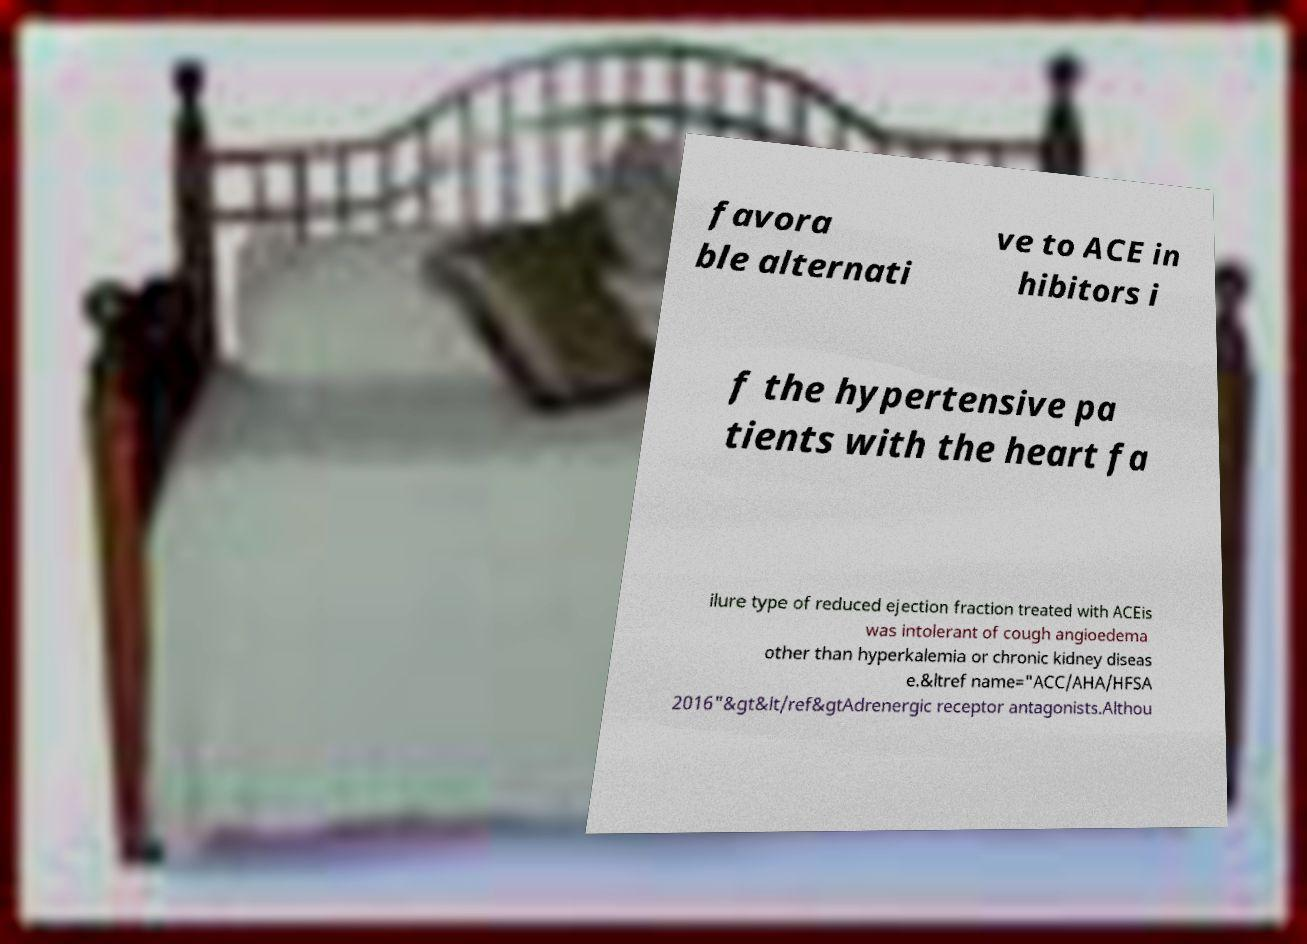I need the written content from this picture converted into text. Can you do that? favora ble alternati ve to ACE in hibitors i f the hypertensive pa tients with the heart fa ilure type of reduced ejection fraction treated with ACEis was intolerant of cough angioedema other than hyperkalemia or chronic kidney diseas e.&ltref name="ACC/AHA/HFSA 2016"&gt&lt/ref&gtAdrenergic receptor antagonists.Althou 